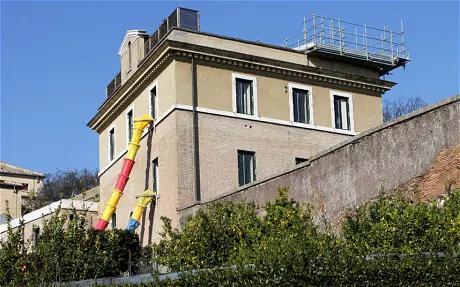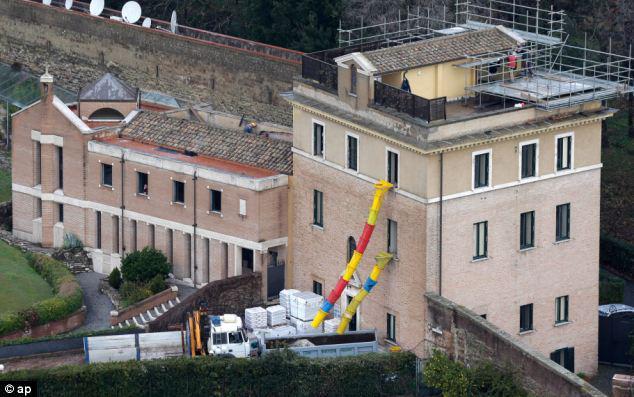The first image is the image on the left, the second image is the image on the right. For the images displayed, is the sentence "There are stairs in the image on the left." factually correct? Answer yes or no. No. 